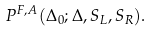<formula> <loc_0><loc_0><loc_500><loc_500>P ^ { F , A } ( \Delta _ { 0 } ; \Delta , S _ { L } , S _ { R } ) .</formula> 